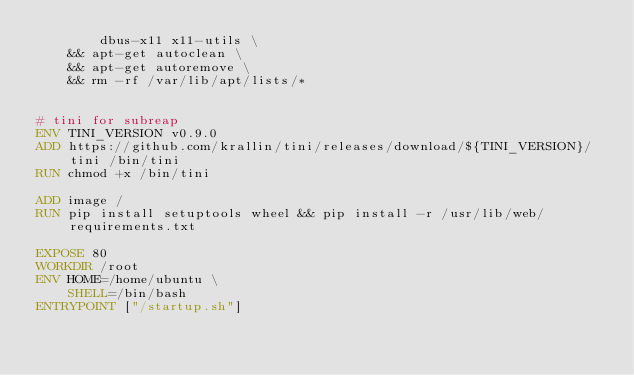<code> <loc_0><loc_0><loc_500><loc_500><_Dockerfile_>        dbus-x11 x11-utils \
    && apt-get autoclean \
    && apt-get autoremove \
    && rm -rf /var/lib/apt/lists/*


# tini for subreap                                   
ENV TINI_VERSION v0.9.0
ADD https://github.com/krallin/tini/releases/download/${TINI_VERSION}/tini /bin/tini
RUN chmod +x /bin/tini

ADD image /
RUN pip install setuptools wheel && pip install -r /usr/lib/web/requirements.txt

EXPOSE 80
WORKDIR /root
ENV HOME=/home/ubuntu \
    SHELL=/bin/bash
ENTRYPOINT ["/startup.sh"]
</code> 